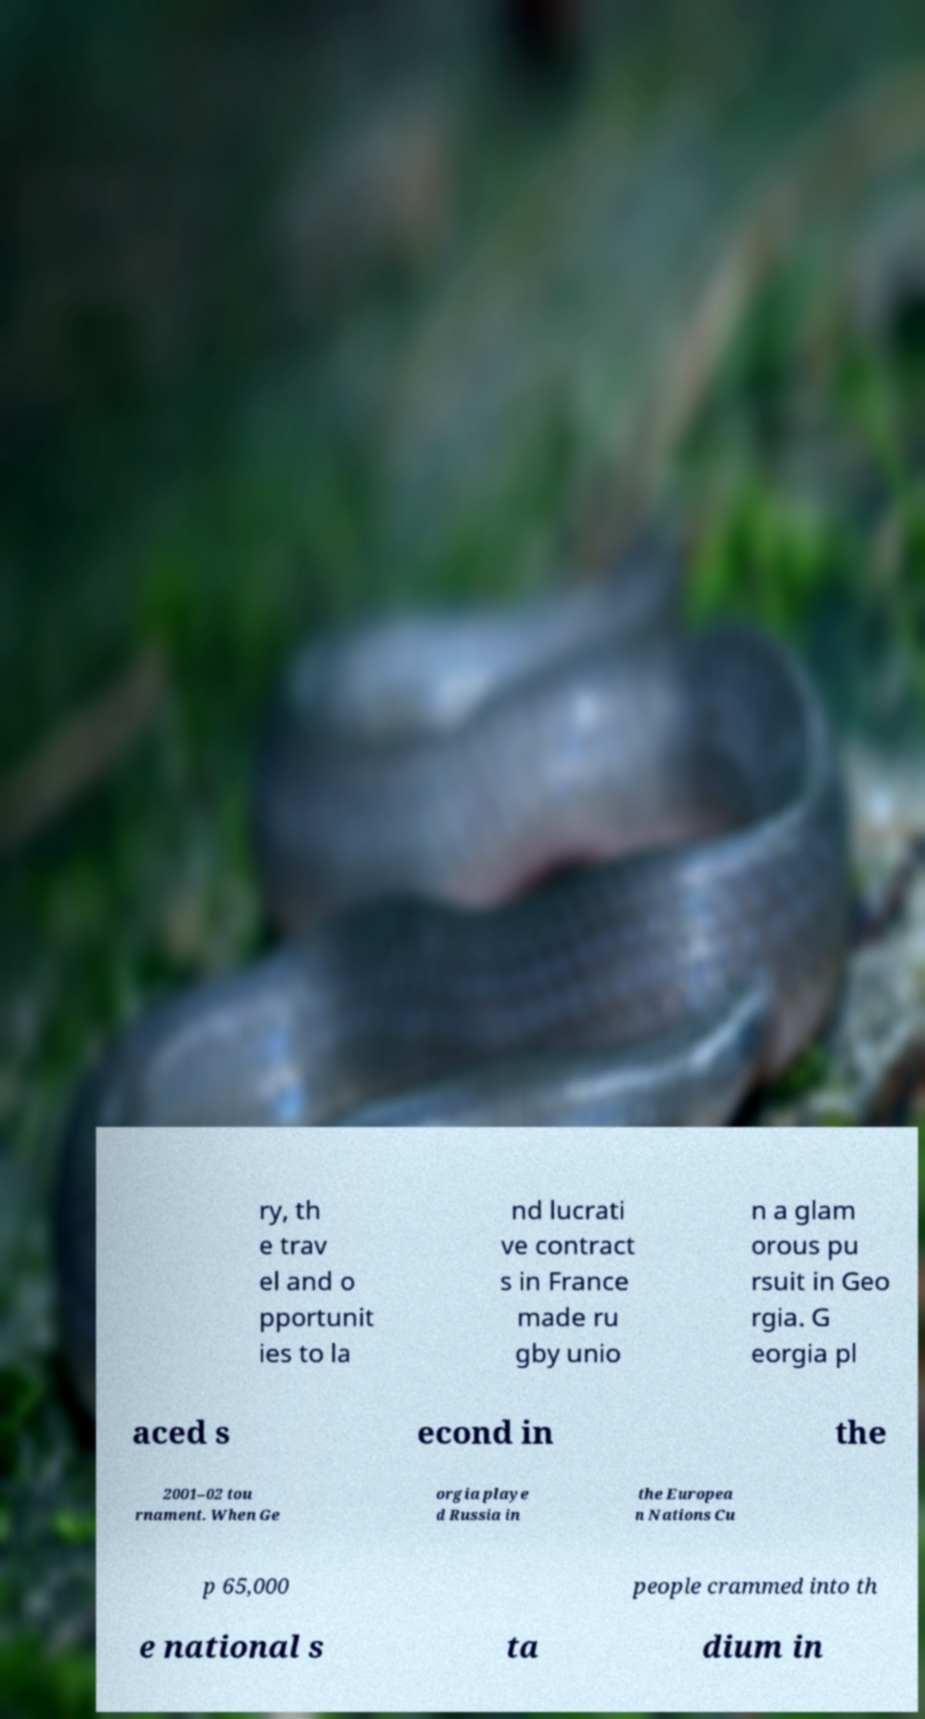Could you extract and type out the text from this image? ry, th e trav el and o pportunit ies to la nd lucrati ve contract s in France made ru gby unio n a glam orous pu rsuit in Geo rgia. G eorgia pl aced s econd in the 2001–02 tou rnament. When Ge orgia playe d Russia in the Europea n Nations Cu p 65,000 people crammed into th e national s ta dium in 